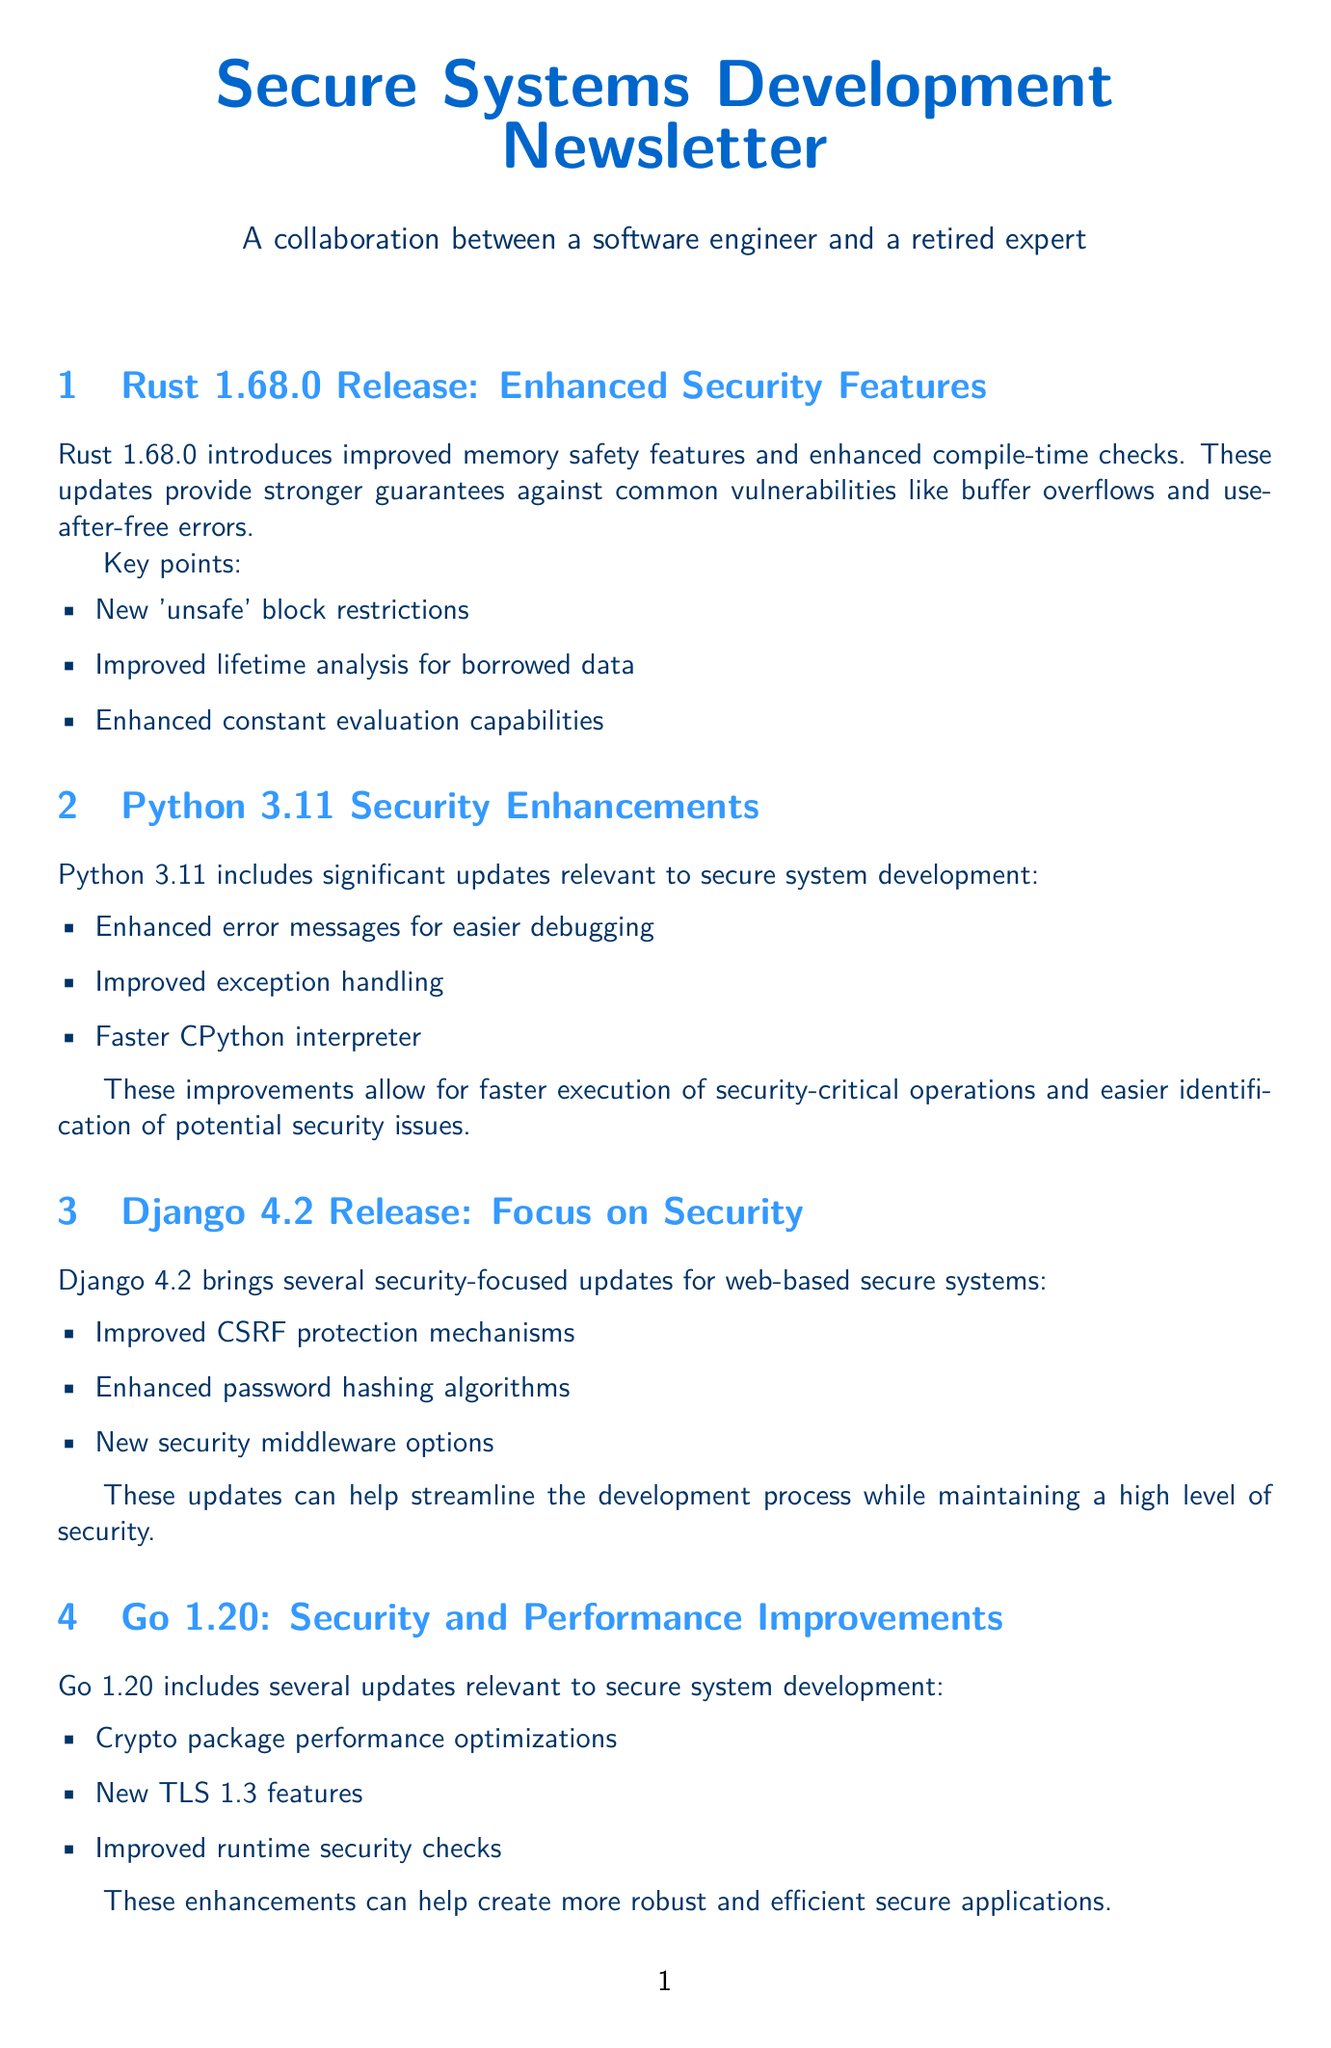What is the version number of Rust mentioned? The document states the latest Rust release as version 1.68.0.
Answer: 1.68.0 How many key points are listed under Rust's updates? The document lists three key points under Rust's updates.
Answer: 3 What feature improvement is highlighted in Python 3.11? Python 3.11 highlights enhanced error messages for easier debugging.
Answer: Enhanced error messages Which Django version focuses on security? The document states that Django version 4.2 brings security-focused updates.
Answer: 4.2 What new feature does Go 1.20 include? Go 1.20 includes new TLS 1.3 features as part of its updates.
Answer: TLS 1.3 features What is a significant focus of Spring Framework version 6.0? The document states that Spring Framework version 6.0 focuses strongly on security.
Answer: Security How many security updates are mentioned for Django 4.2? The document mentions three security updates for Django 4.2.
Answer: 3 What is the main purpose of the newsletter? The main purpose of the newsletter is to provide updates on programming languages and frameworks for secure system development.
Answer: Updates on programming languages and frameworks 